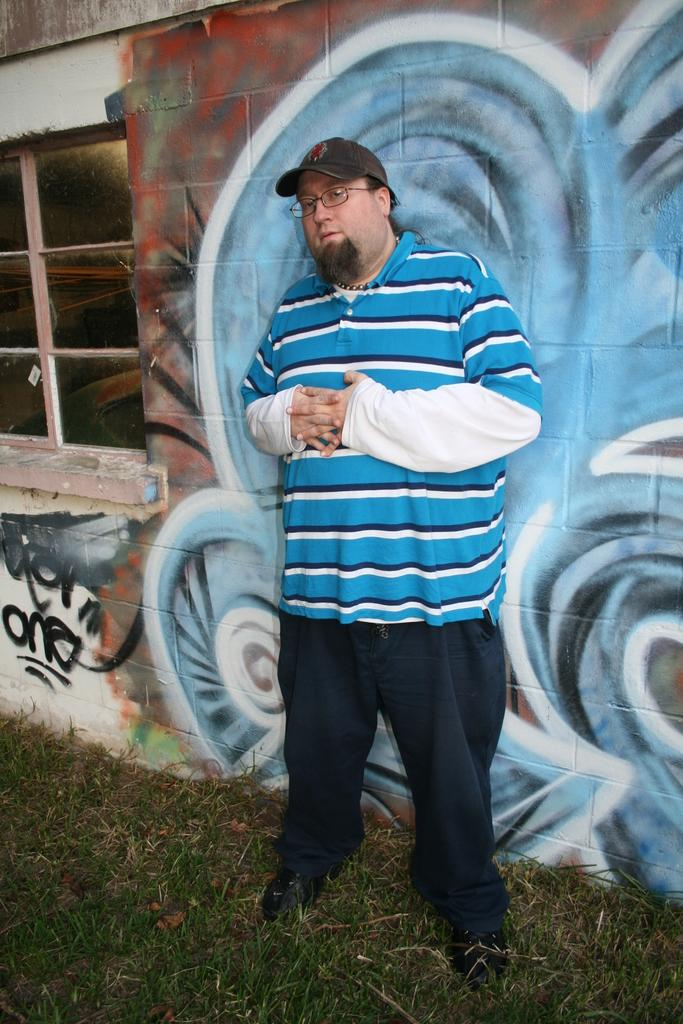What is the main subject of the picture? The main subject of the picture is a man standing. Can you describe the man's attire in the image? The man is wearing a cap on his head and spectacles on his face. What can be seen on the wall in the image? There is a painting on the wall in the image. What architectural feature is present in the image? There is a glass window in the image. What type of natural environment is visible in the image? Grass is visible on the ground in the image. What type of instrument is the man playing in the image? There is no instrument present in the image; the man is not playing any instrument. Can you describe the bee buzzing around the man's head in the image? There is no bee present in the image; the man is not interacting with any bees. 